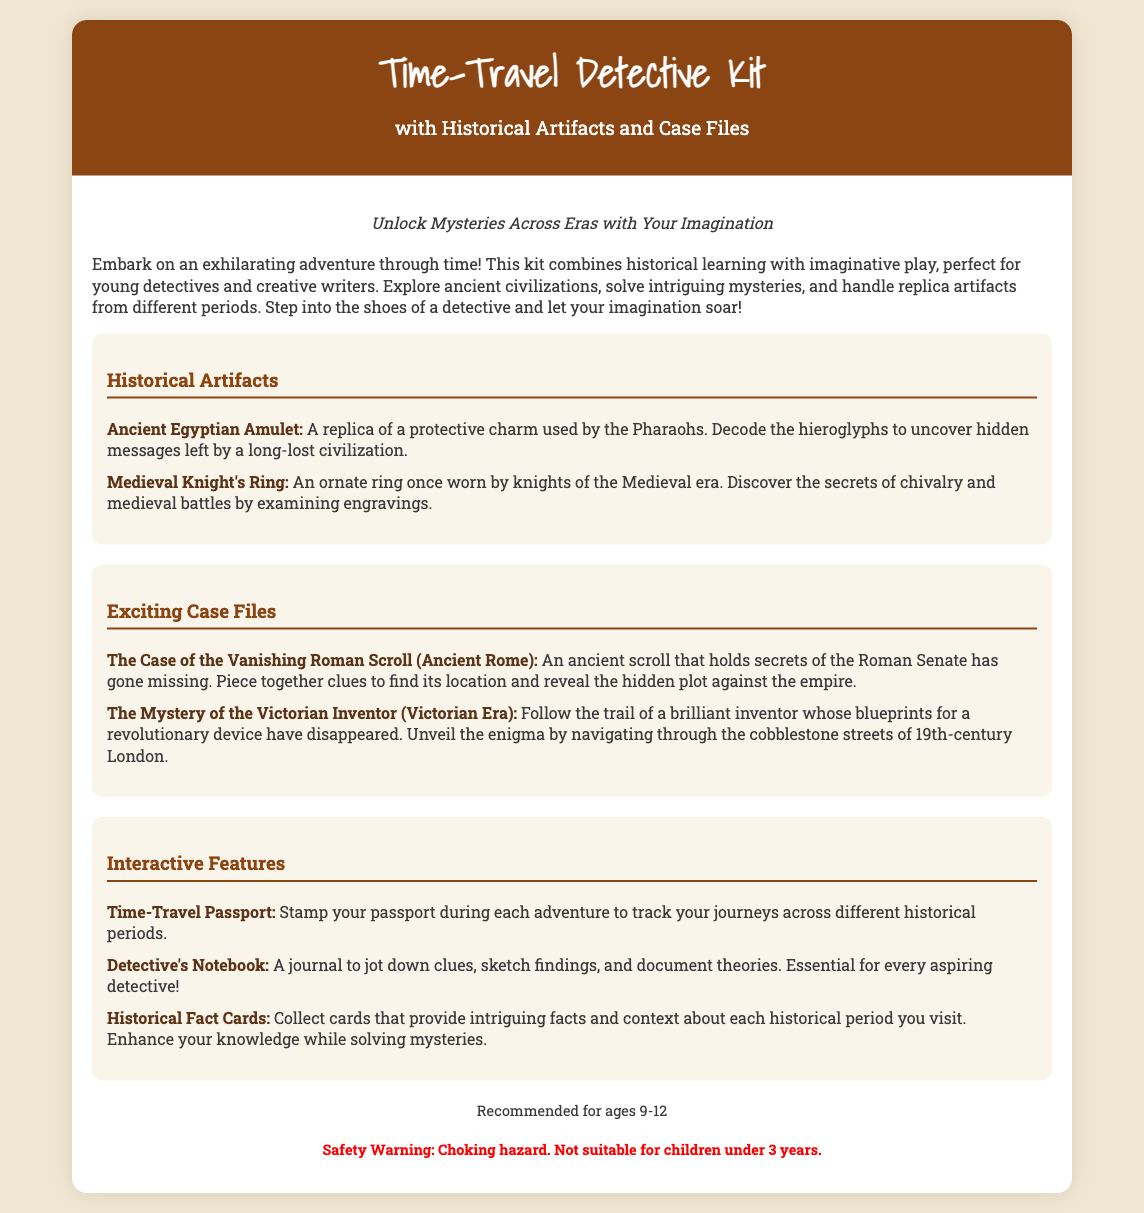What is the name of the kit? The kit is called the Time-Travel Detective Kit, as stated in the header.
Answer: Time-Travel Detective Kit What age range is this kit recommended for? The recommended age range is explicitly stated in the document.
Answer: 9-12 Name one of the historical artifacts included. The document lists specific artifacts, including an Ancient Egyptian Amulet and a Medieval Knight's Ring.
Answer: Ancient Egyptian Amulet What is the title of the first case file? The first case file is mentioned in the section on exciting case files, referencing "The Case of the Vanishing Roman Scroll."
Answer: The Case of the Vanishing Roman Scroll What is the purpose of the Detective's Notebook? The text details that the Detective's Notebook is essential for jotting down clues, sketching findings, and documenting theories.
Answer: Jot down clues List one interactive feature of the kit. The section on interactive features describes several, including a Time-Travel Passport and Historical Fact Cards.
Answer: Time-Travel Passport What safety warning is provided in the document? The document includes a clear safety warning regarding choking hazards for young children.
Answer: Choking hazard What are the intended activities for users of this kit? The document describes activities that include solving mysteries and exploring ancient civilizations.
Answer: Solving mysteries 